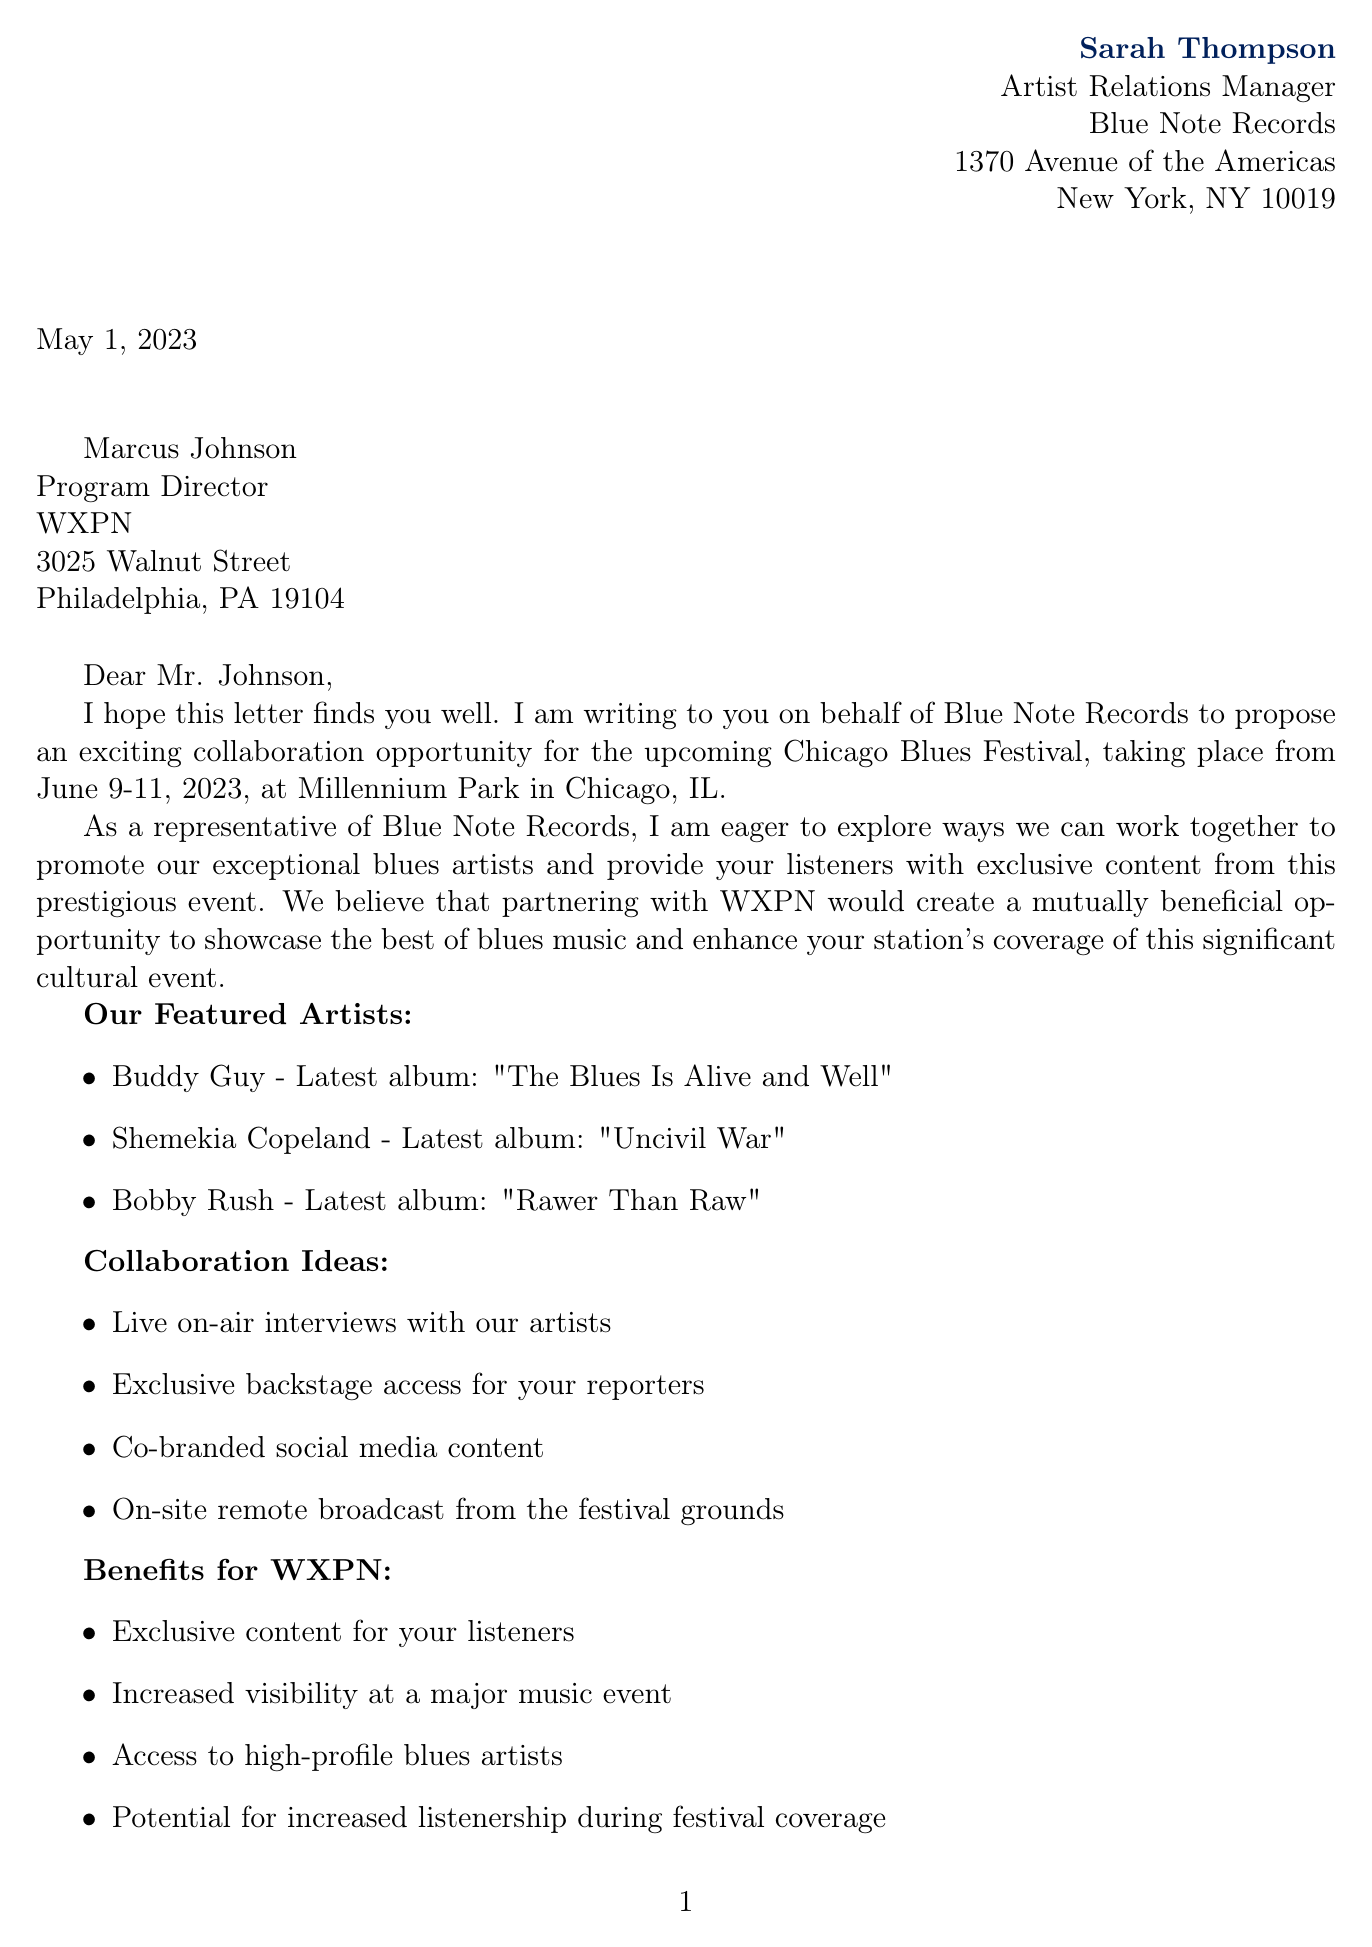what is the name of the sender? The sender's name is mentioned at the top of the document, indicating who is writing the letter.
Answer: Sarah Thompson what is the title of the recipient? The title of the recipient is provided along with their name, helping to identify their role.
Answer: Program Director when is the Chicago Blues Festival scheduled? The document specifies the dates for the Chicago Blues Festival, making it clear when the event will take place.
Answer: June 9-11, 2023 how many artists are mentioned in the document? The document lists the blues artists that Blue Note Records wants to promote, indicating the number of featured artists.
Answer: Three what benefit does WXPN gain from the collaboration? The document outlines multiple benefits for the radio station, which highlights the advantages of the proposed partnership.
Answer: Exclusive content for your listeners what is the proposed meeting date? The document clearly states the date for when the sender wishes to hold an initial meeting to discuss collaboration details.
Answer: May 1, 2023 how many collaboration ideas are listed? The document includes a list of collaboration ideas, which showcases various potential ways to work together.
Answer: Four what type of special performance is offered? The additional offerings in the document mention a unique aspect of the collaboration that includes a performance.
Answer: Acoustic set by one of our artists at your studio what merchandise is offered for listener giveaways? The document specifies what kind of merchandise will be available for promotion during the collaboration.
Answer: Signed vinyl records and posters 